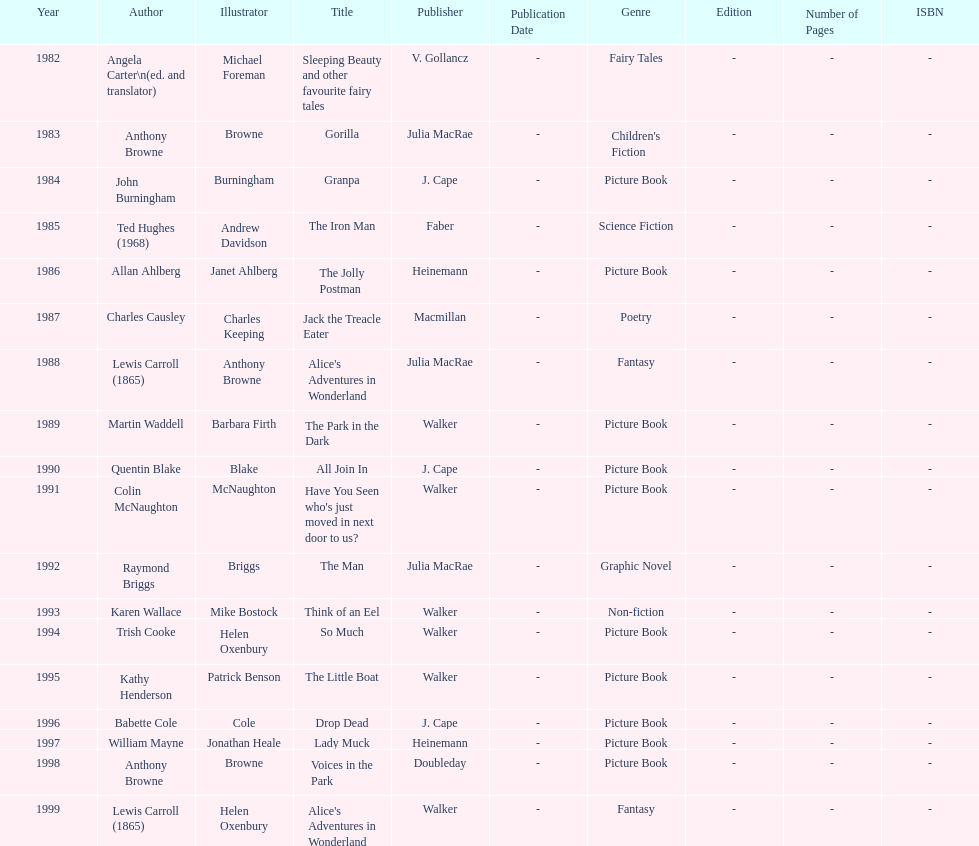How many titles did walker publish? 6. 